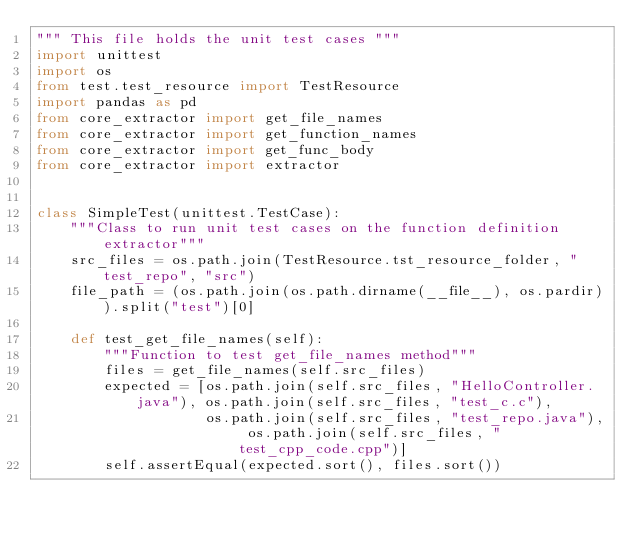<code> <loc_0><loc_0><loc_500><loc_500><_Python_>""" This file holds the unit test cases """
import unittest
import os
from test.test_resource import TestResource
import pandas as pd
from core_extractor import get_file_names
from core_extractor import get_function_names
from core_extractor import get_func_body
from core_extractor import extractor


class SimpleTest(unittest.TestCase):
    """Class to run unit test cases on the function definition extractor"""
    src_files = os.path.join(TestResource.tst_resource_folder, "test_repo", "src")
    file_path = (os.path.join(os.path.dirname(__file__), os.pardir)).split("test")[0]

    def test_get_file_names(self):
        """Function to test get_file_names method"""
        files = get_file_names(self.src_files)
        expected = [os.path.join(self.src_files, "HelloController.java"), os.path.join(self.src_files, "test_c.c"),
                    os.path.join(self.src_files, "test_repo.java"), os.path.join(self.src_files, "test_cpp_code.cpp")]
        self.assertEqual(expected.sort(), files.sort())
</code> 